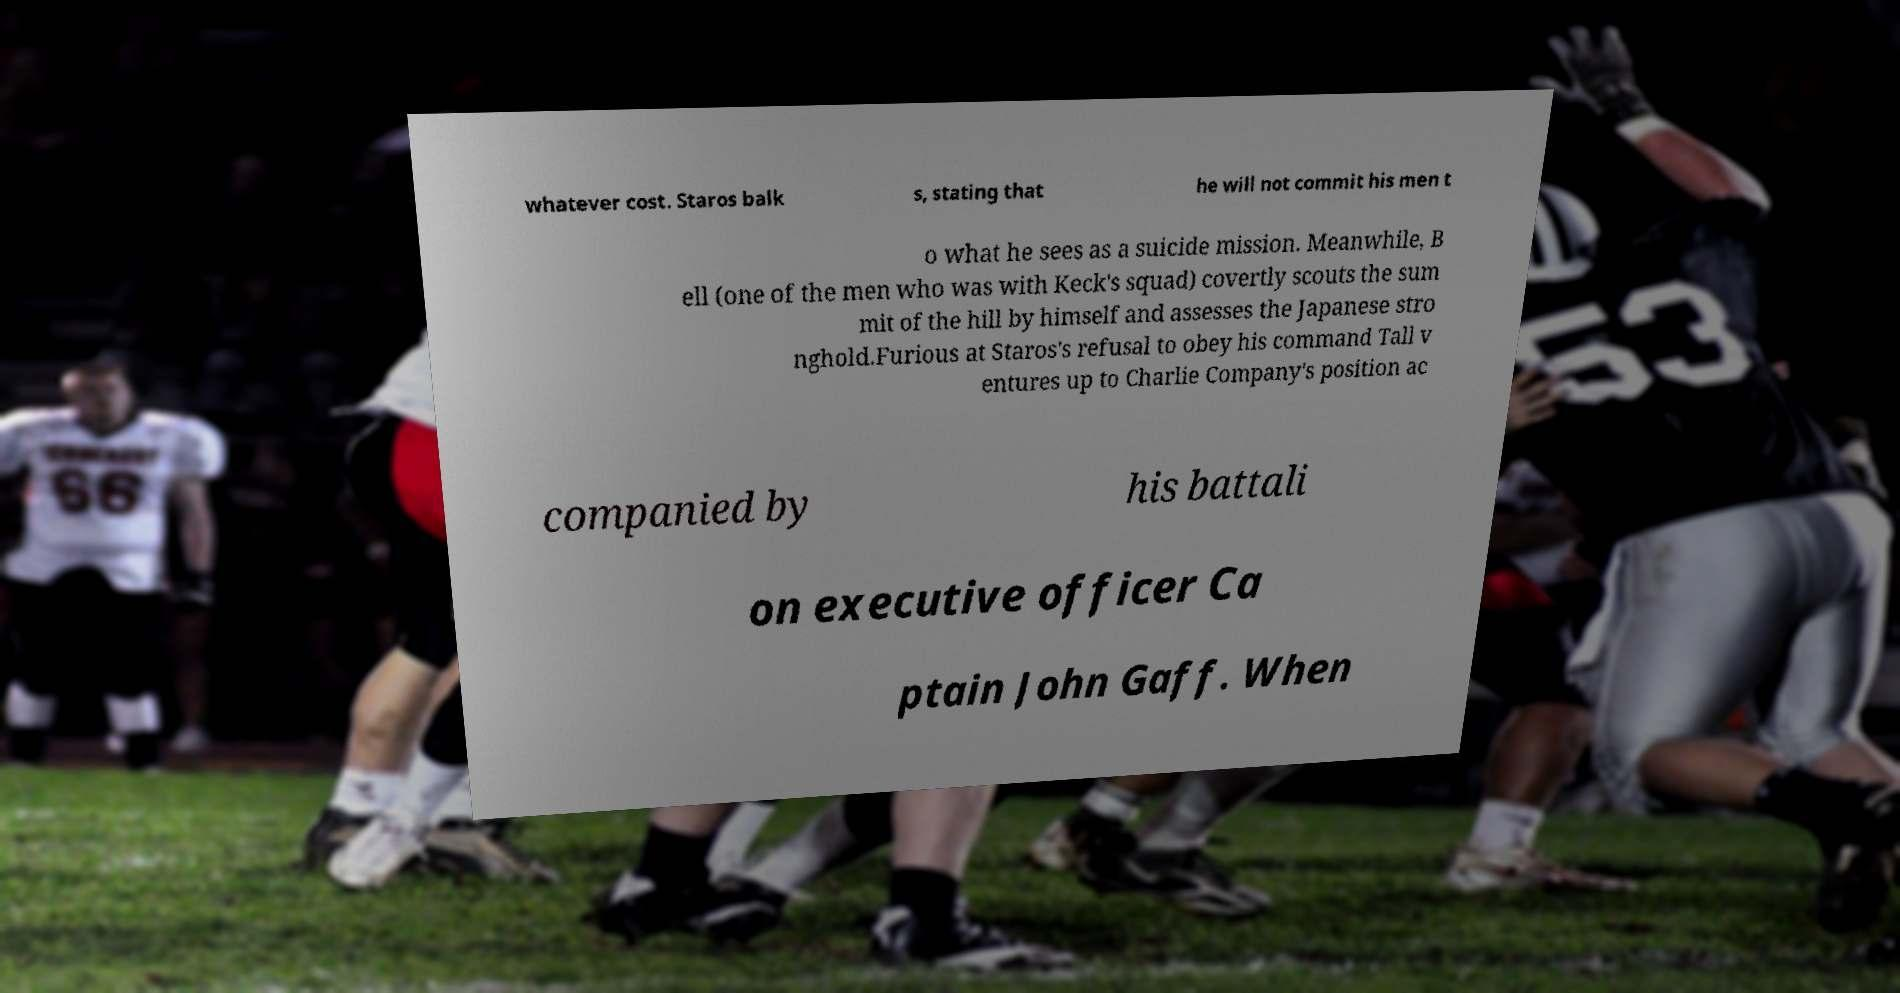What messages or text are displayed in this image? I need them in a readable, typed format. whatever cost. Staros balk s, stating that he will not commit his men t o what he sees as a suicide mission. Meanwhile, B ell (one of the men who was with Keck's squad) covertly scouts the sum mit of the hill by himself and assesses the Japanese stro nghold.Furious at Staros's refusal to obey his command Tall v entures up to Charlie Company's position ac companied by his battali on executive officer Ca ptain John Gaff. When 